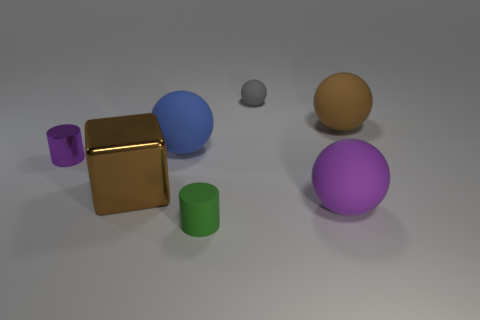Subtract all purple spheres. How many spheres are left? 3 Add 1 large cyan rubber spheres. How many objects exist? 8 Subtract all green cylinders. How many cylinders are left? 1 Subtract 0 brown cylinders. How many objects are left? 7 Subtract all cylinders. How many objects are left? 5 Subtract 1 cylinders. How many cylinders are left? 1 Subtract all brown cylinders. Subtract all red balls. How many cylinders are left? 2 Subtract all brown cylinders. How many purple balls are left? 1 Subtract all small red matte cylinders. Subtract all matte spheres. How many objects are left? 3 Add 1 brown blocks. How many brown blocks are left? 2 